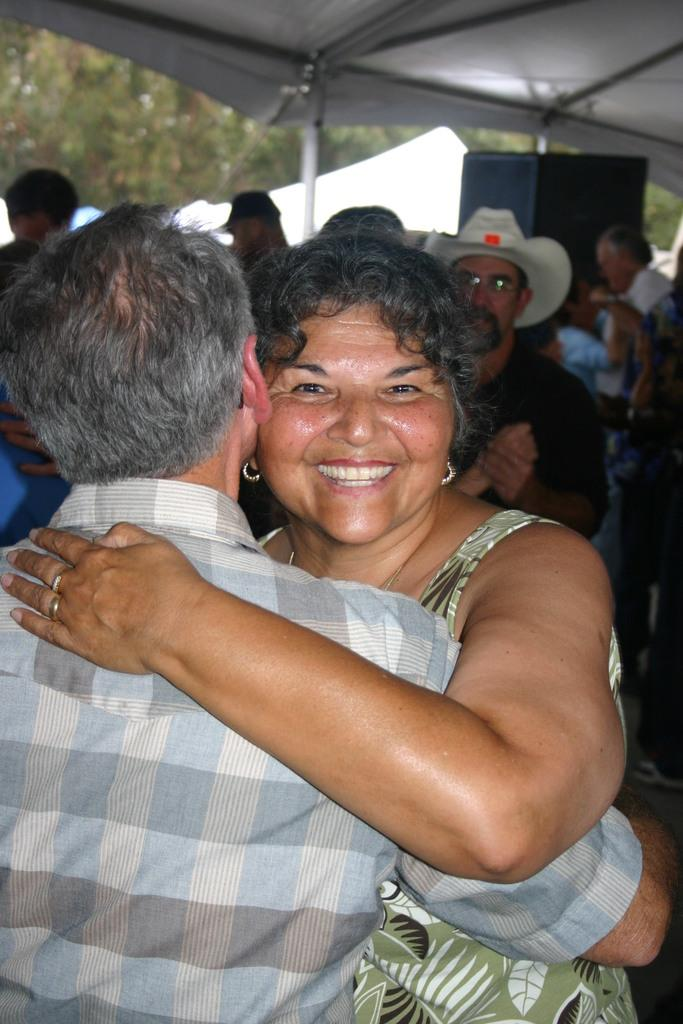How many people are present in the image? There are two people in the image, a man and a woman. What are the man and woman doing in the image? The man and woman are hugging each other. What can be seen in the background of the image? There is a group of people, a speaker, a tent, trees, and a roof visible in the background. What type of store can be seen in the image? There is no store present in the image. What effect does the hug have on the people in the image? The image does not show any specific effect on the people; it only shows them hugging. 